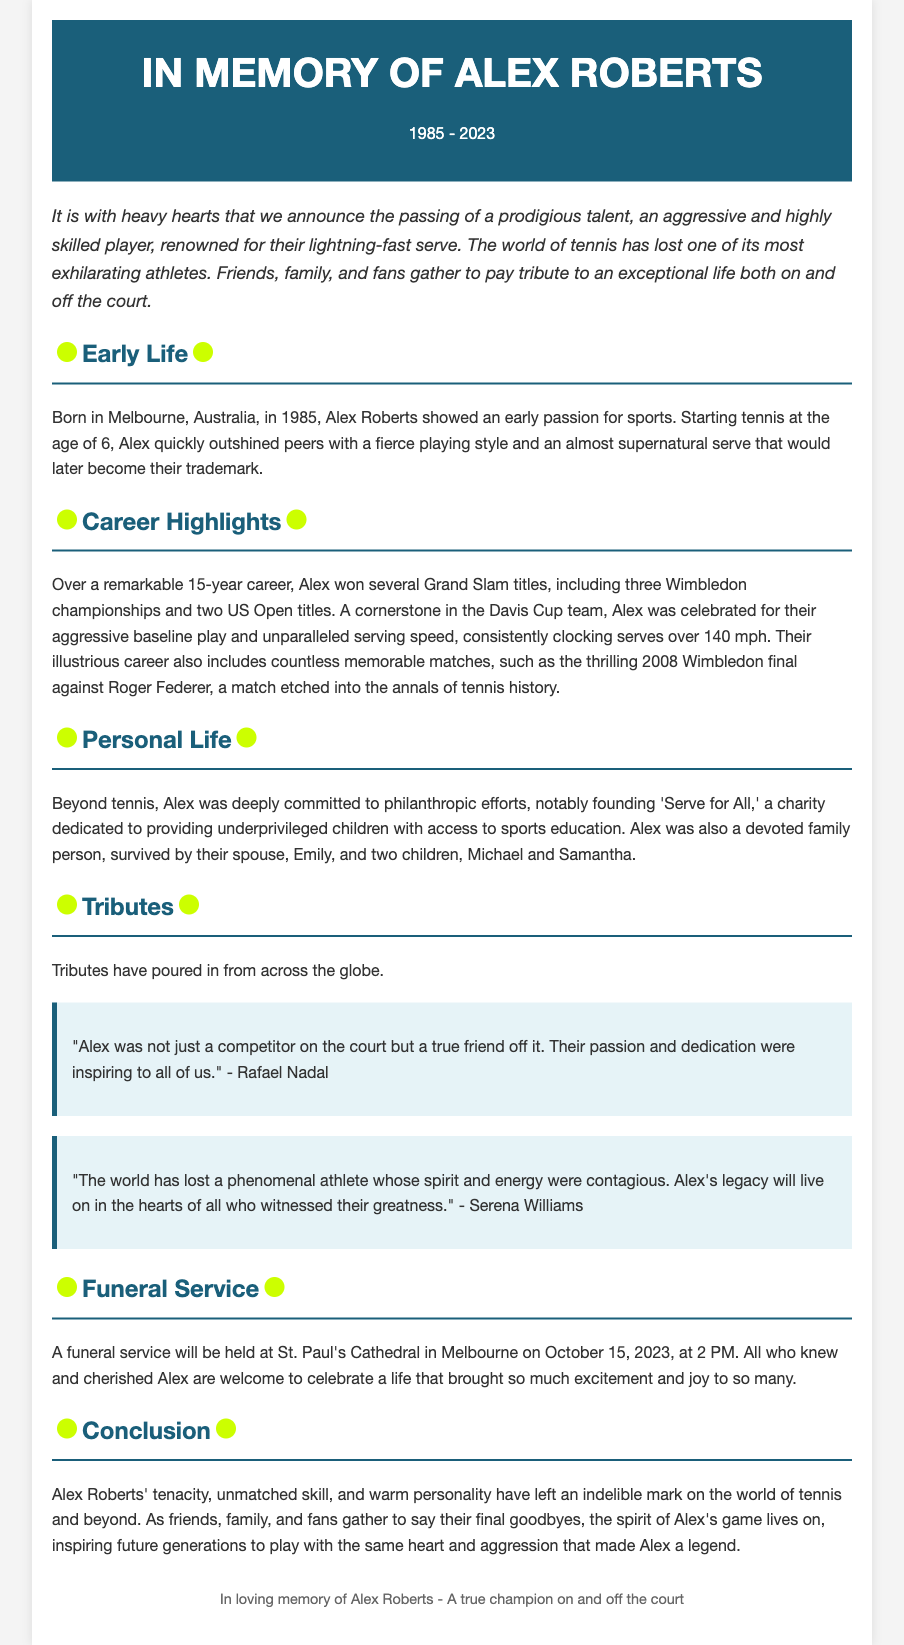what year was Alex Roberts born? The document states that Alex Roberts was born in 1985.
Answer: 1985 how many Grand Slam titles did Alex win? The document mentions that Alex won several Grand Slam titles, specifying three Wimbledon championships and two US Open titles, totaling five.
Answer: Five where will the funeral service be held? The document specifies that the funeral service will be at St. Paul's Cathedral in Melbourne.
Answer: St. Paul's Cathedral in Melbourne who described Alex as a true friend off the court? Rafael Nadal is quoted in the document as describing Alex in that way.
Answer: Rafael Nadal what was the primary occupation of Alex Roberts? The document identifies Alex Roberts primarily as a professional tennis player.
Answer: Professional tennis player how many children did Alex have? The document states that Alex is survived by two children, Michael and Samantha.
Answer: Two what charity did Alex found? The document mentions that Alex founded 'Serve for All,' a charity dedicated to sports education.
Answer: Serve for All which year did Alex pass away? The document notes that Alex passed away in 2023.
Answer: 2023 what was Alex known for on the tennis court? The document describes Alex as being known for their aggressive playing style and lightning-fast serve.
Answer: Aggressive playing style and lightning-fast serve 